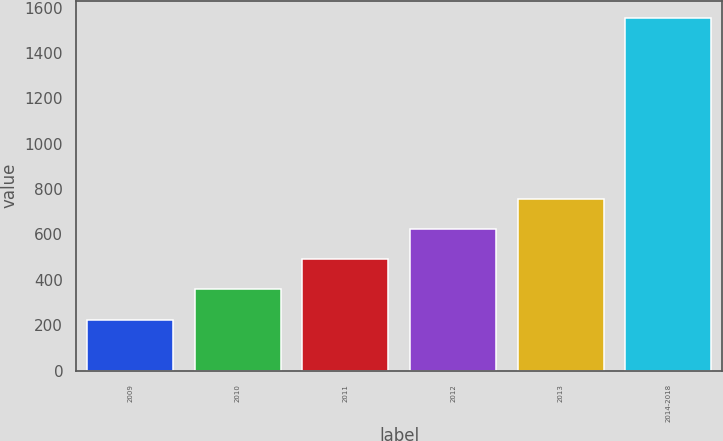Convert chart. <chart><loc_0><loc_0><loc_500><loc_500><bar_chart><fcel>2009<fcel>2010<fcel>2011<fcel>2012<fcel>2013<fcel>2014-2018<nl><fcel>225<fcel>357.7<fcel>490.4<fcel>623.1<fcel>755.8<fcel>1552<nl></chart> 